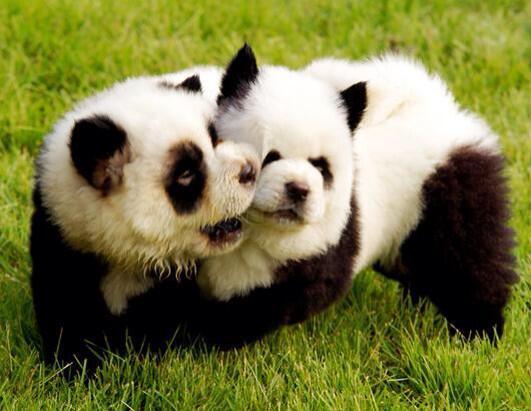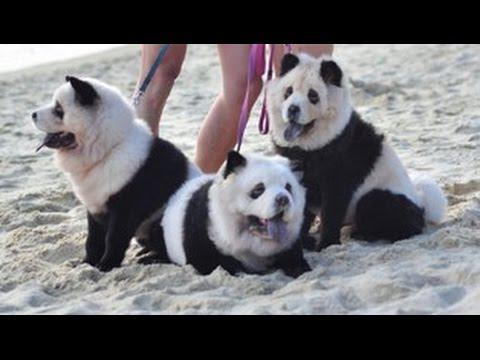The first image is the image on the left, the second image is the image on the right. Given the left and right images, does the statement "An image shows three panda-look chows, with one reclining and two sitting up." hold true? Answer yes or no. Yes. The first image is the image on the left, the second image is the image on the right. Considering the images on both sides, is "There's at least three dogs in the right image." valid? Answer yes or no. Yes. 